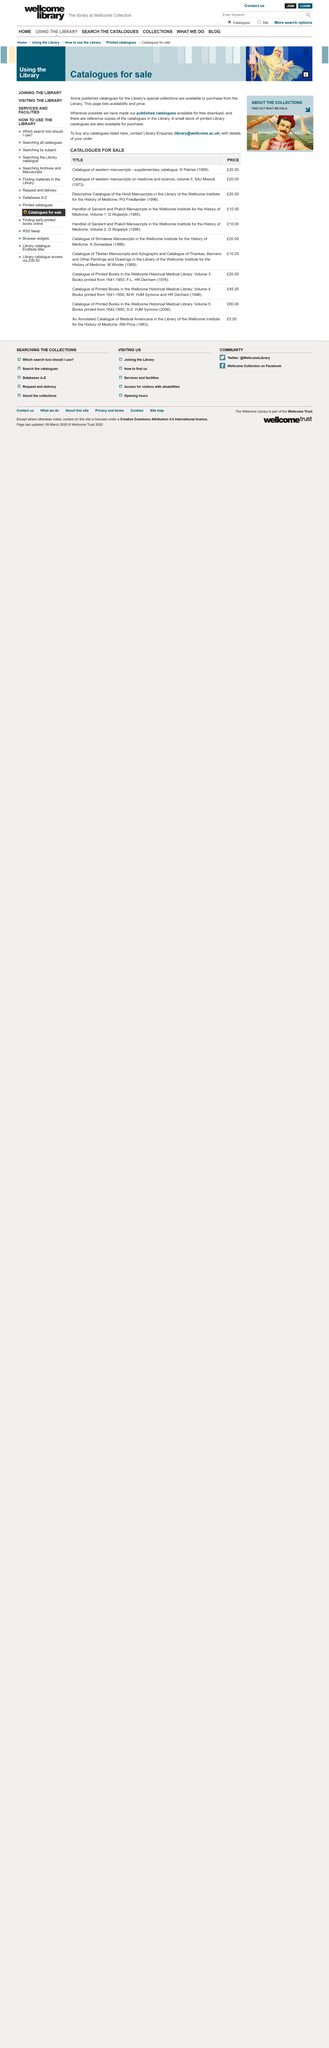Point out several critical features in this image. The word "catalogues" appears six times. If one desires to purchase catalogs, the individual should contact the library's enquiries department. 